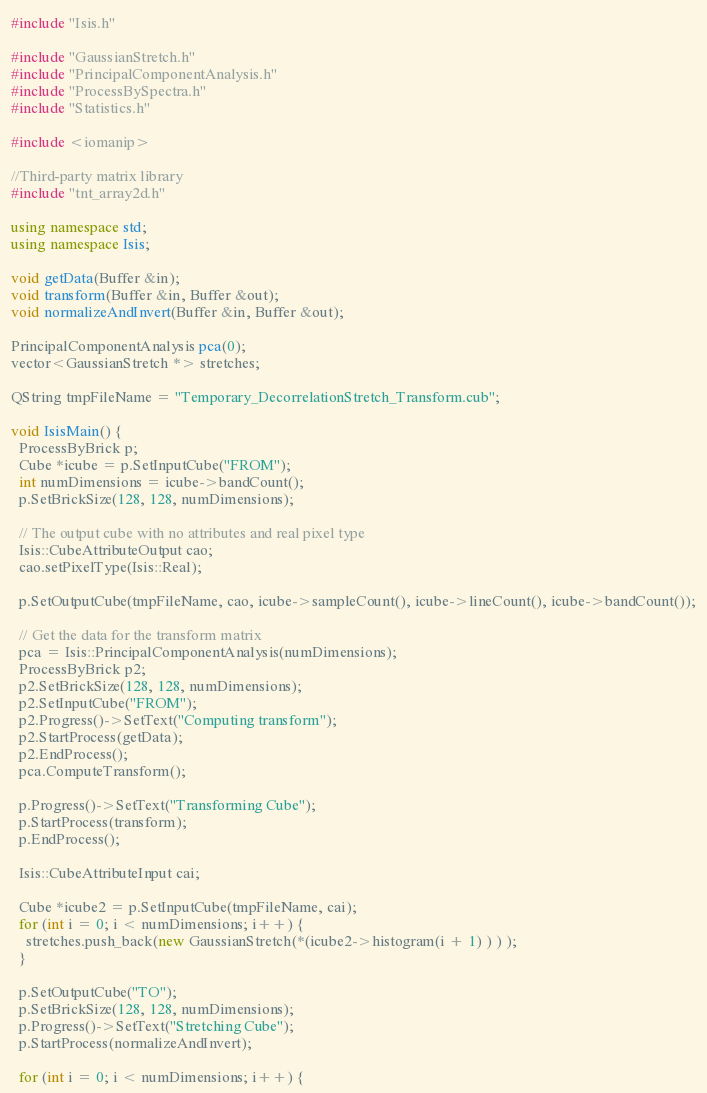Convert code to text. <code><loc_0><loc_0><loc_500><loc_500><_C++_>#include "Isis.h"

#include "GaussianStretch.h"
#include "PrincipalComponentAnalysis.h"
#include "ProcessBySpectra.h"
#include "Statistics.h"

#include <iomanip>

//Third-party matrix library
#include "tnt_array2d.h"

using namespace std;
using namespace Isis;

void getData(Buffer &in);
void transform(Buffer &in, Buffer &out);
void normalizeAndInvert(Buffer &in, Buffer &out);

PrincipalComponentAnalysis pca(0);
vector<GaussianStretch *> stretches;

QString tmpFileName = "Temporary_DecorrelationStretch_Transform.cub";

void IsisMain() {
  ProcessByBrick p;
  Cube *icube = p.SetInputCube("FROM");
  int numDimensions = icube->bandCount();
  p.SetBrickSize(128, 128, numDimensions);

  // The output cube with no attributes and real pixel type
  Isis::CubeAttributeOutput cao;
  cao.setPixelType(Isis::Real);

  p.SetOutputCube(tmpFileName, cao, icube->sampleCount(), icube->lineCount(), icube->bandCount());

  // Get the data for the transform matrix
  pca = Isis::PrincipalComponentAnalysis(numDimensions);
  ProcessByBrick p2;
  p2.SetBrickSize(128, 128, numDimensions);
  p2.SetInputCube("FROM");
  p2.Progress()->SetText("Computing transform");
  p2.StartProcess(getData);
  p2.EndProcess();
  pca.ComputeTransform();

  p.Progress()->SetText("Transforming Cube");
  p.StartProcess(transform);
  p.EndProcess();

  Isis::CubeAttributeInput cai;

  Cube *icube2 = p.SetInputCube(tmpFileName, cai);
  for (int i = 0; i < numDimensions; i++) {
    stretches.push_back(new GaussianStretch(*(icube2->histogram(i + 1) ) ) );
  }

  p.SetOutputCube("TO");
  p.SetBrickSize(128, 128, numDimensions);
  p.Progress()->SetText("Stretching Cube");
  p.StartProcess(normalizeAndInvert);

  for (int i = 0; i < numDimensions; i++) {</code> 